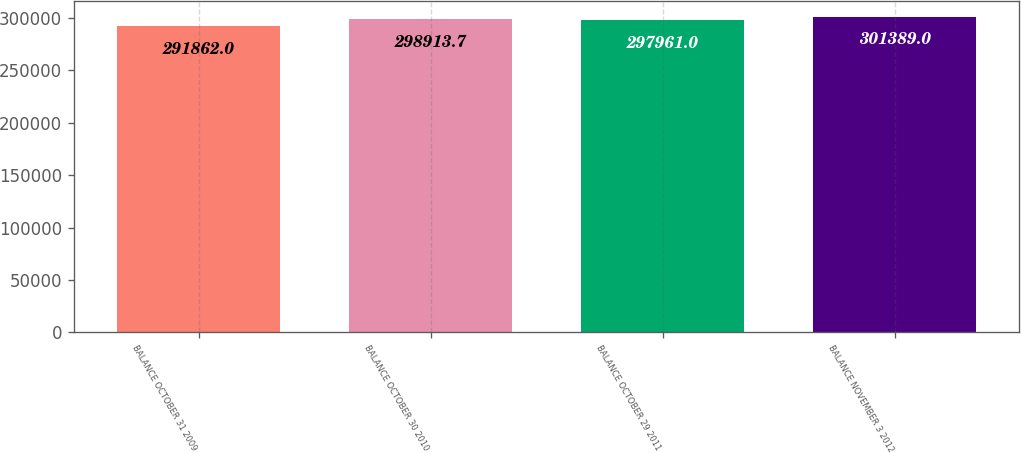Convert chart. <chart><loc_0><loc_0><loc_500><loc_500><bar_chart><fcel>BALANCE OCTOBER 31 2009<fcel>BALANCE OCTOBER 30 2010<fcel>BALANCE OCTOBER 29 2011<fcel>BALANCE NOVEMBER 3 2012<nl><fcel>291862<fcel>298914<fcel>297961<fcel>301389<nl></chart> 